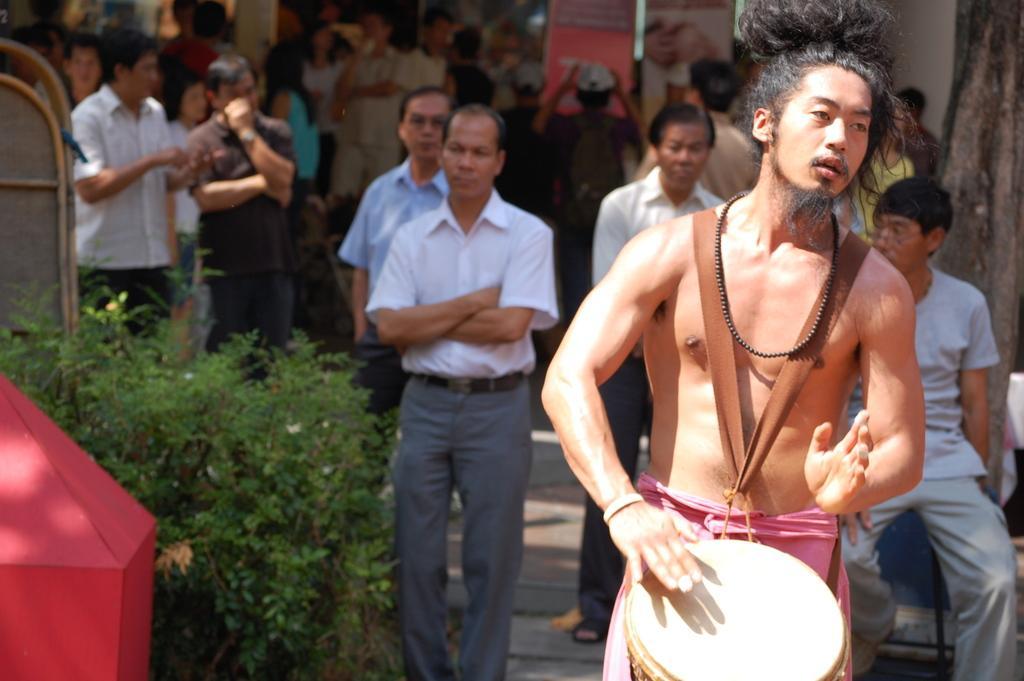Can you describe this image briefly? In this picture there are people, among them there is a man playing a drum and we can see planets, objects and tree trunk. In the background of the image we can see boards. 